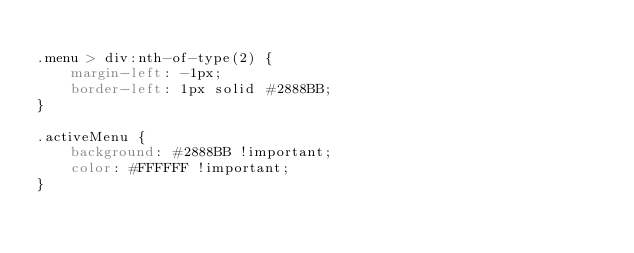Convert code to text. <code><loc_0><loc_0><loc_500><loc_500><_CSS_>
.menu > div:nth-of-type(2) {
    margin-left: -1px;
    border-left: 1px solid #2888BB;
}

.activeMenu {
    background: #2888BB !important;
    color: #FFFFFF !important;
}</code> 